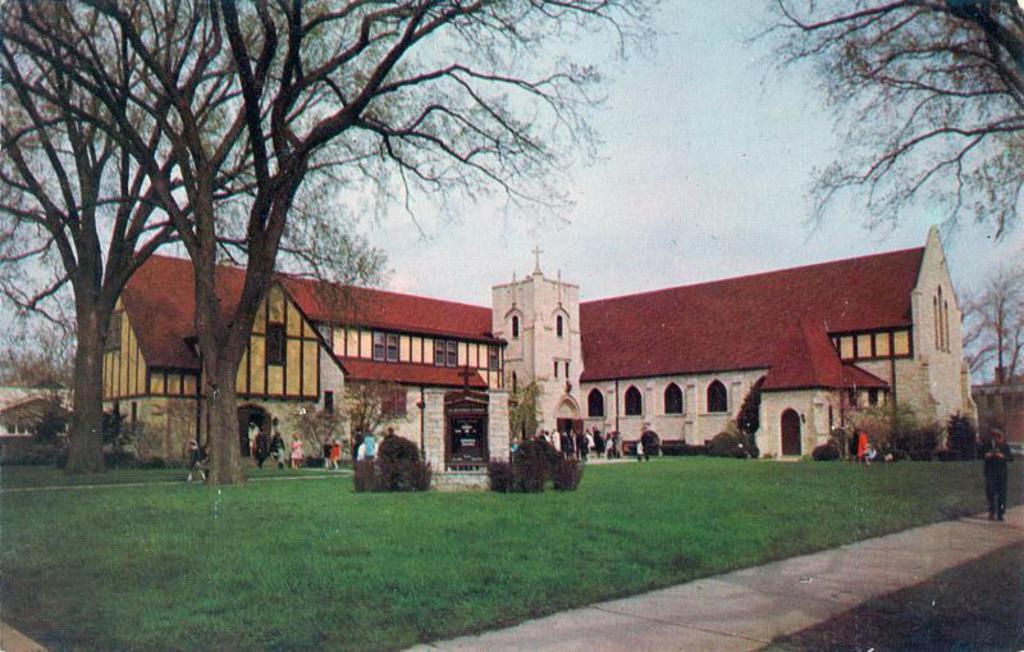Please provide a concise description of this image. At the bottom of the image on the ground there is grass. In the image there is a building with walls, windows and roofs. And also there are few trees. There are few people standing in front of the building. At the top of the image there is a sky. On the right side of the image there is a man on the path. 